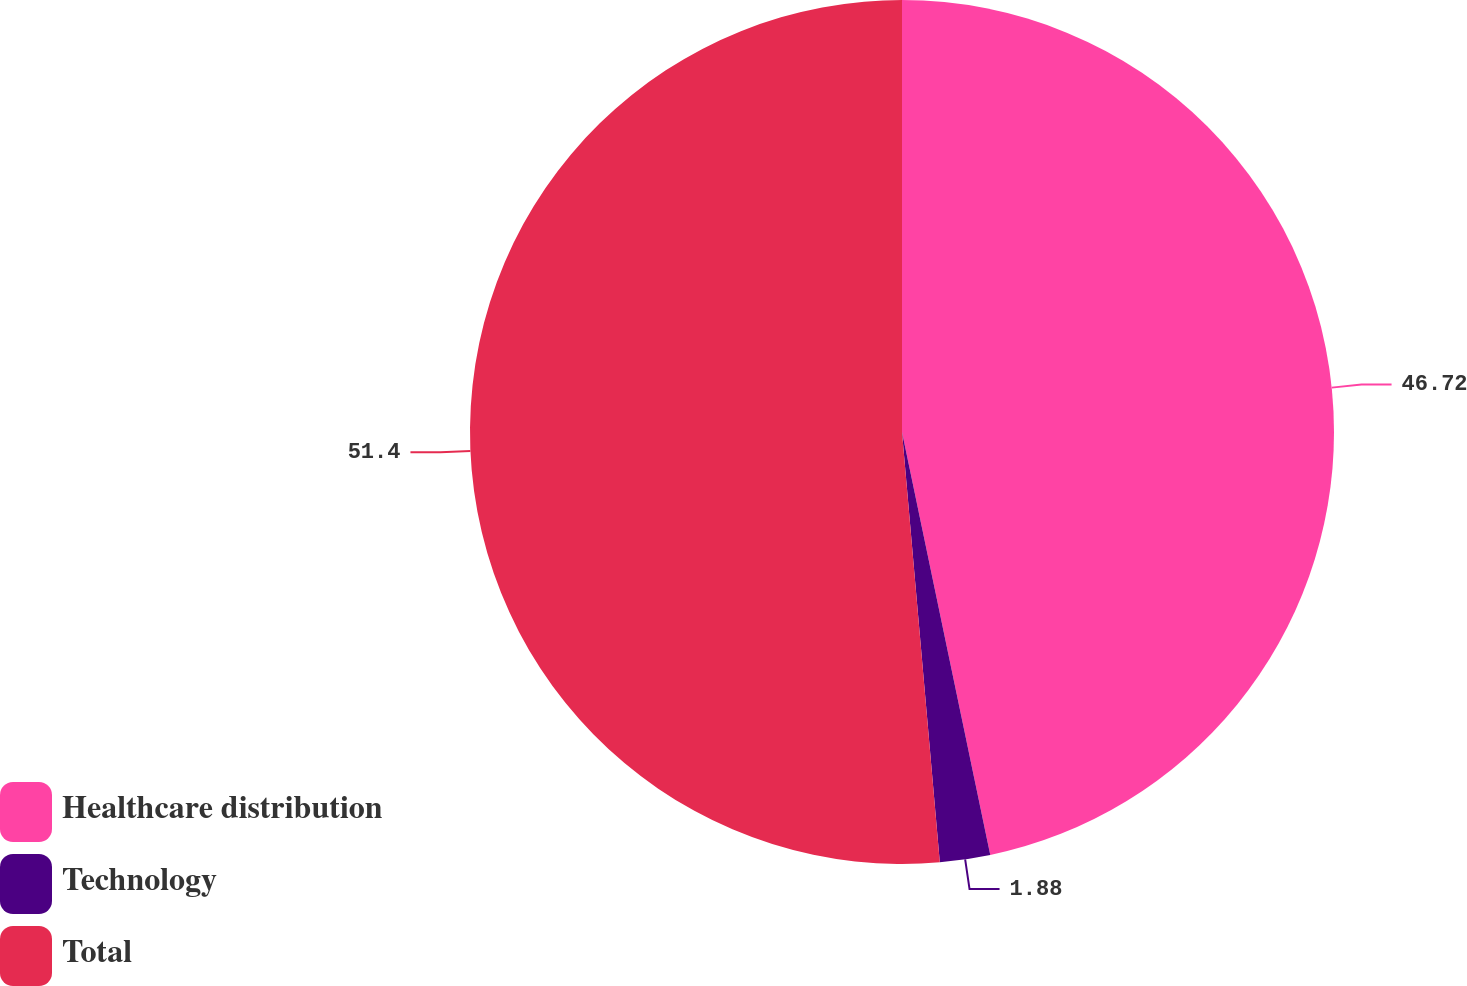<chart> <loc_0><loc_0><loc_500><loc_500><pie_chart><fcel>Healthcare distribution<fcel>Technology<fcel>Total<nl><fcel>46.72%<fcel>1.88%<fcel>51.39%<nl></chart> 